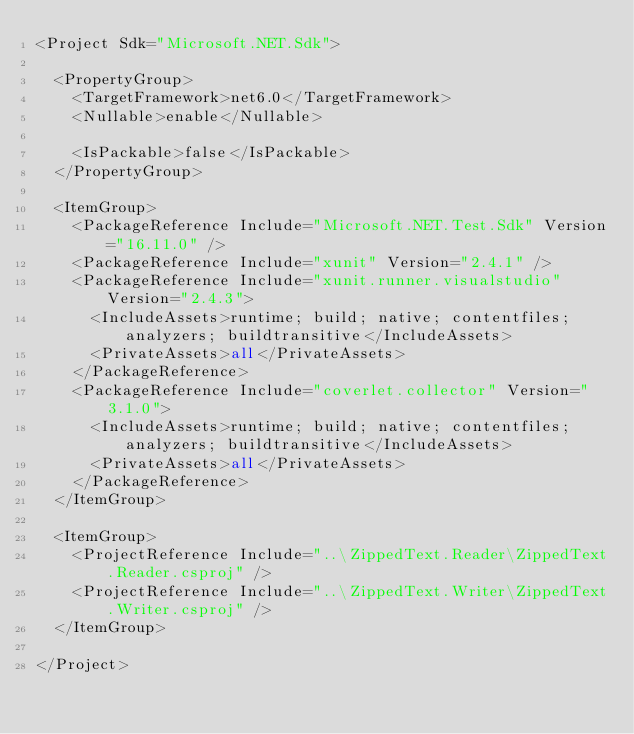Convert code to text. <code><loc_0><loc_0><loc_500><loc_500><_XML_><Project Sdk="Microsoft.NET.Sdk">

  <PropertyGroup>
    <TargetFramework>net6.0</TargetFramework>
    <Nullable>enable</Nullable>

    <IsPackable>false</IsPackable>
  </PropertyGroup>

  <ItemGroup>
    <PackageReference Include="Microsoft.NET.Test.Sdk" Version="16.11.0" />
    <PackageReference Include="xunit" Version="2.4.1" />
    <PackageReference Include="xunit.runner.visualstudio" Version="2.4.3">
      <IncludeAssets>runtime; build; native; contentfiles; analyzers; buildtransitive</IncludeAssets>
      <PrivateAssets>all</PrivateAssets>
    </PackageReference>
    <PackageReference Include="coverlet.collector" Version="3.1.0">
      <IncludeAssets>runtime; build; native; contentfiles; analyzers; buildtransitive</IncludeAssets>
      <PrivateAssets>all</PrivateAssets>
    </PackageReference>
  </ItemGroup>

  <ItemGroup>
    <ProjectReference Include="..\ZippedText.Reader\ZippedText.Reader.csproj" />
    <ProjectReference Include="..\ZippedText.Writer\ZippedText.Writer.csproj" />
  </ItemGroup>

</Project>
</code> 